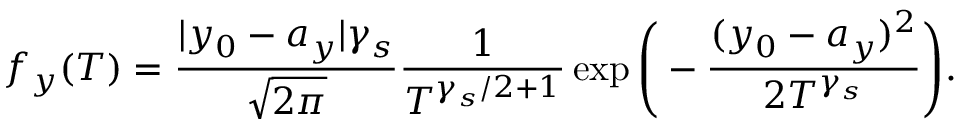Convert formula to latex. <formula><loc_0><loc_0><loc_500><loc_500>f _ { y } ( T ) = \frac { | y _ { 0 } - a _ { y } | \gamma _ { s } } { \sqrt { 2 \pi } } \frac { 1 } { T ^ { \gamma _ { s } / 2 + 1 } } \exp \left ( - \frac { ( y _ { 0 } - a _ { y } ) ^ { 2 } } { 2 T ^ { \gamma _ { s } } } \right ) .</formula> 